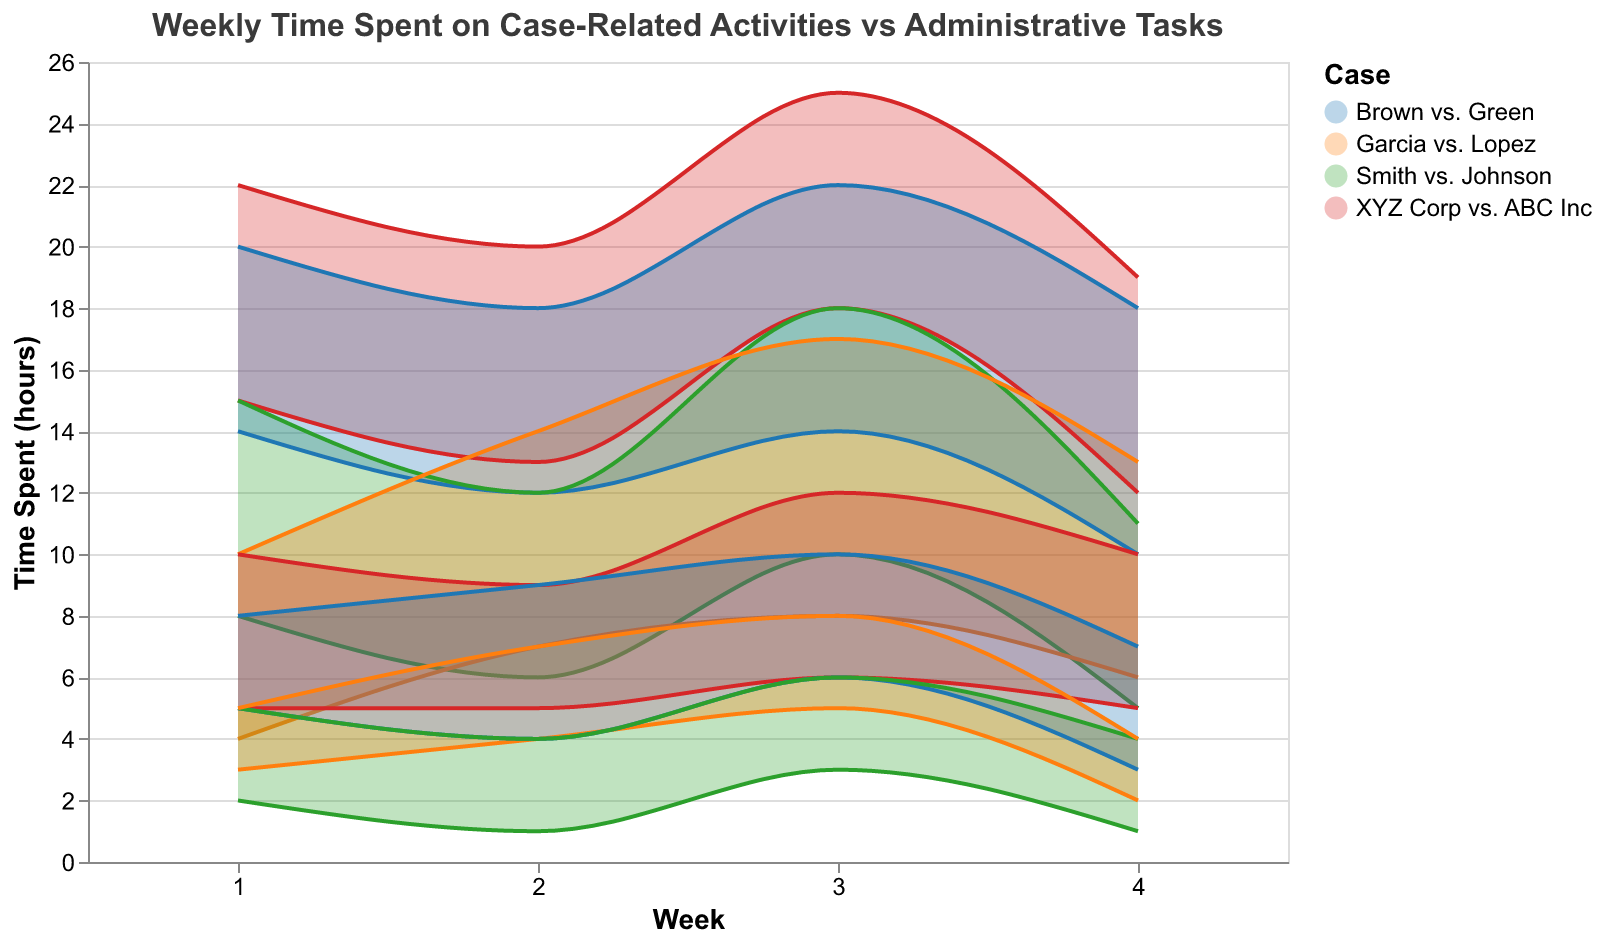What is the title of the figure? The title is located at the top of the figure, usually prominently displayed. It provides a summary of what the data in the chart represents.
Answer: Weekly Time Spent on Case-Related Activities vs Administrative Tasks How many weeks are shown in the data for each case? The x-axis of the chart represents the weeks, and it runs from 1 to 4, indicating the range of weeks covered in the data.
Answer: 4 Which case sees the maximum time spent on case-related activities in any week, and what is that maximum time? The tallest area indicating case-related activities peaks for "XYZ Corp vs. ABC Inc" in Week 3. The maximum time spent value is given by the "MinTimeSpent(Max)" for that week.
Answer: XYZ Corp vs. ABC Inc, 25 hours Between Weeks 2 and 3, which case shows the largest increase in time spent on case-related activities? To determine the largest increase, we look at the difference in "MinTimeSpent(Max)" values between Weeks 2 and 3 for each case. The largest difference is seen in "XYZ Corp vs. ABC Inc," where the time increased from 20 to 25 hours, an increase of 5 hours.
Answer: XYZ Corp vs. ABC Inc Which case has the least variation in time spent on administrative tasks across the weeks? We need to look at the differences between "MaxAdmTasks(Max)" and "MaxAdmTasks(Min)" for each week and average them for each case. "Smith vs. Johnson" seems to have consistently lower variations.
Answer: Smith vs. Johnson What is the average maximum time spent on administrative tasks for "Brown vs. Green" across all weeks? Sum the "MaxAdmTasks(Max)" values for all weeks and divide by the number of weeks (4). (8+9+10+7) / 4 = 34 / 4 = 8.5 hours
Answer: 8.5 hours In Week 1, which case had the highest minimum time spent on case-related activities? Compare the "MinTimeSpent(Min)" values for Week 1 among all cases. "XYZ Corp vs. ABC Inc" has the highest minimum time spent which is 15 hours.
Answer: XYZ Corp vs. ABC Inc Does any case show a consistent decline in time spent on case-related activities from Week 1 to Week 4? To find a consistent decline, check the "MinTimeSpent(Max)" values across weeks for each case. "Garcia vs. Lopez" shows a decrease in both maximum and minimum values.
Answer: Garcia vs. Lopez How does the range of time spent on administrative tasks for "XYZ Corp vs. ABC Inc" in Week 3 compare to the range in Week 4? Calculate the ranges by subtracting "MaxAdmTasks(Min)" from "MaxAdmTasks(Max)" for both weeks. For Week 3, it is 12-6=6 hours; for Week 4, it is 10-5=5 hours.
Answer: Week 3: 6 hours, Week 4: 5 hours 